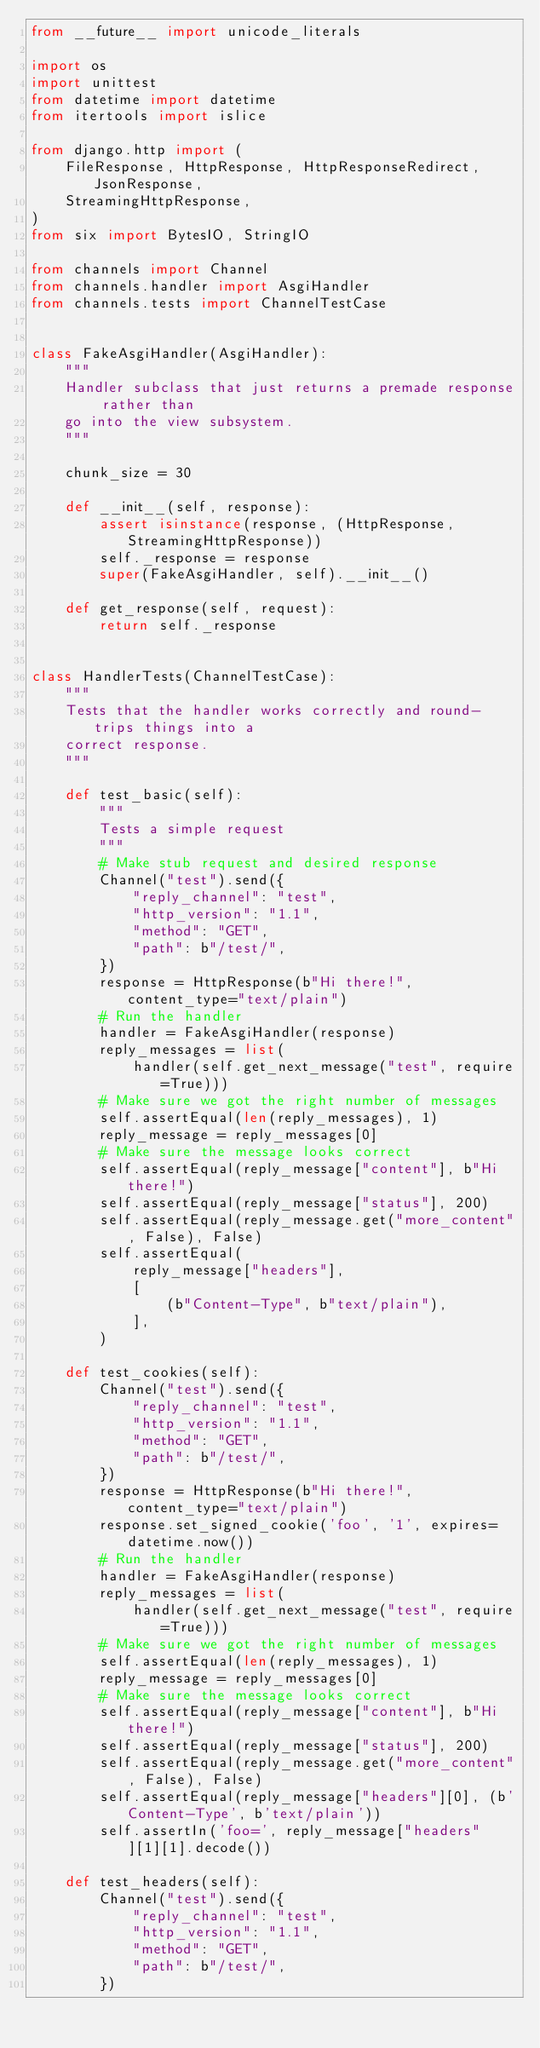Convert code to text. <code><loc_0><loc_0><loc_500><loc_500><_Python_>from __future__ import unicode_literals

import os
import unittest
from datetime import datetime
from itertools import islice

from django.http import (
    FileResponse, HttpResponse, HttpResponseRedirect, JsonResponse,
    StreamingHttpResponse,
)
from six import BytesIO, StringIO

from channels import Channel
from channels.handler import AsgiHandler
from channels.tests import ChannelTestCase


class FakeAsgiHandler(AsgiHandler):
    """
    Handler subclass that just returns a premade response rather than
    go into the view subsystem.
    """

    chunk_size = 30

    def __init__(self, response):
        assert isinstance(response, (HttpResponse, StreamingHttpResponse))
        self._response = response
        super(FakeAsgiHandler, self).__init__()

    def get_response(self, request):
        return self._response


class HandlerTests(ChannelTestCase):
    """
    Tests that the handler works correctly and round-trips things into a
    correct response.
    """

    def test_basic(self):
        """
        Tests a simple request
        """
        # Make stub request and desired response
        Channel("test").send({
            "reply_channel": "test",
            "http_version": "1.1",
            "method": "GET",
            "path": b"/test/",
        })
        response = HttpResponse(b"Hi there!", content_type="text/plain")
        # Run the handler
        handler = FakeAsgiHandler(response)
        reply_messages = list(
            handler(self.get_next_message("test", require=True)))
        # Make sure we got the right number of messages
        self.assertEqual(len(reply_messages), 1)
        reply_message = reply_messages[0]
        # Make sure the message looks correct
        self.assertEqual(reply_message["content"], b"Hi there!")
        self.assertEqual(reply_message["status"], 200)
        self.assertEqual(reply_message.get("more_content", False), False)
        self.assertEqual(
            reply_message["headers"],
            [
                (b"Content-Type", b"text/plain"),
            ],
        )

    def test_cookies(self):
        Channel("test").send({
            "reply_channel": "test",
            "http_version": "1.1",
            "method": "GET",
            "path": b"/test/",
        })
        response = HttpResponse(b"Hi there!", content_type="text/plain")
        response.set_signed_cookie('foo', '1', expires=datetime.now())
        # Run the handler
        handler = FakeAsgiHandler(response)
        reply_messages = list(
            handler(self.get_next_message("test", require=True)))
        # Make sure we got the right number of messages
        self.assertEqual(len(reply_messages), 1)
        reply_message = reply_messages[0]
        # Make sure the message looks correct
        self.assertEqual(reply_message["content"], b"Hi there!")
        self.assertEqual(reply_message["status"], 200)
        self.assertEqual(reply_message.get("more_content", False), False)
        self.assertEqual(reply_message["headers"][0], (b'Content-Type', b'text/plain'))
        self.assertIn('foo=', reply_message["headers"][1][1].decode())

    def test_headers(self):
        Channel("test").send({
            "reply_channel": "test",
            "http_version": "1.1",
            "method": "GET",
            "path": b"/test/",
        })</code> 